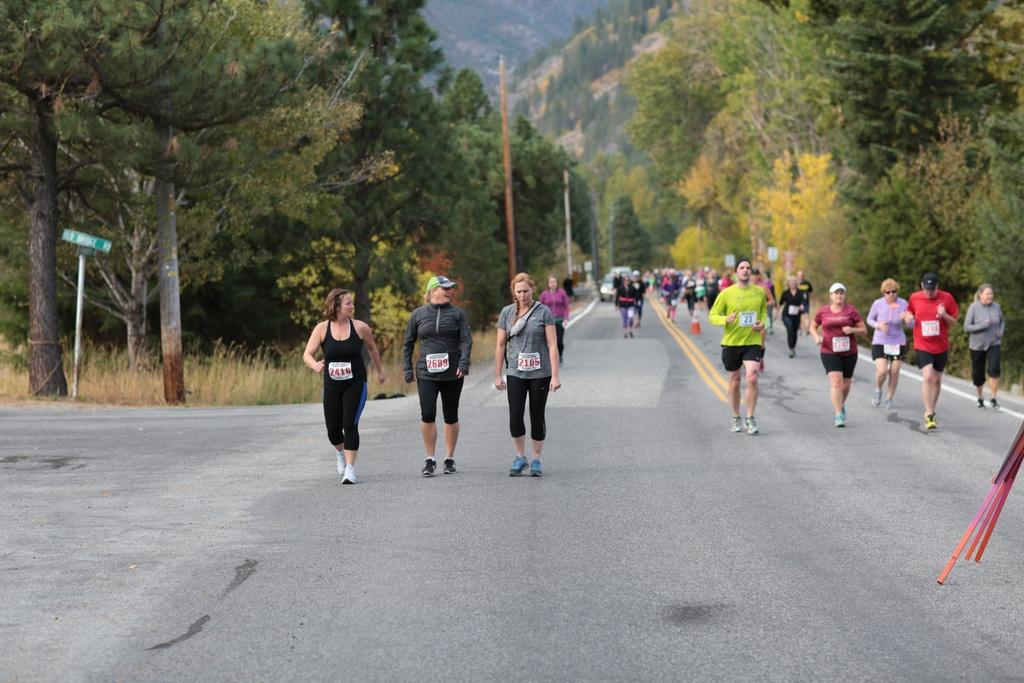What type of natural environment can be seen in the background of the image? There is a thicket in the background of the image. What type of vegetation is present in the image? There are trees and plants in the image. What man-made structures can be seen in the image? There are poles and boards in the image. What object is used to direct traffic in the image? There is a traffic cone in the image. Are there any people visible in the image? Yes, there are people visible in the image. What else can be seen in the image besides the mentioned objects and people? There are objects and a vehicle visible far in the image. Who is the owner of the sticks seen in the image? There are no sticks present in the image. Can you tell me the address of the mailbox in the image? There is no mailbox present in the image. 